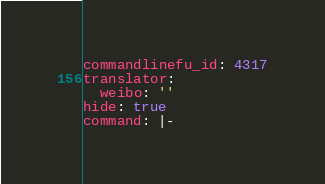<code> <loc_0><loc_0><loc_500><loc_500><_YAML_>commandlinefu_id: 4317
translator:
  weibo: ''
hide: true
command: |-</code> 